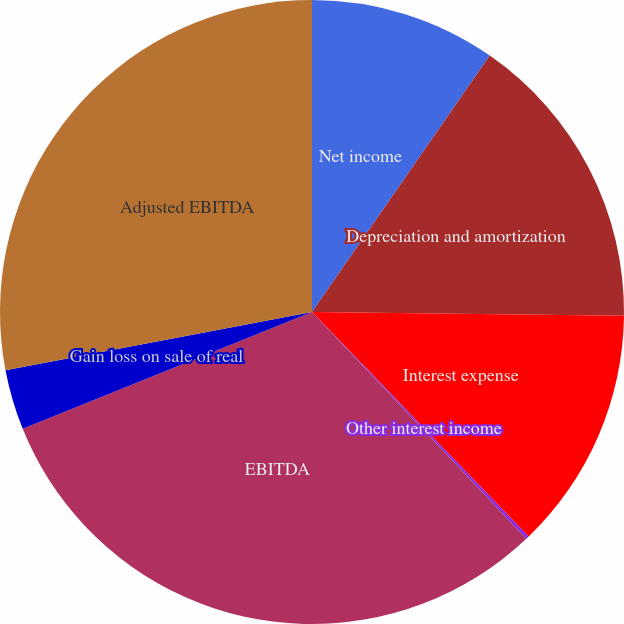Convert chart. <chart><loc_0><loc_0><loc_500><loc_500><pie_chart><fcel>Net income<fcel>Depreciation and amortization<fcel>Interest expense<fcel>Other interest income<fcel>EBITDA<fcel>Gain loss on sale of real<fcel>Adjusted EBITDA<nl><fcel>9.65%<fcel>15.54%<fcel>12.59%<fcel>0.17%<fcel>30.94%<fcel>3.12%<fcel>27.99%<nl></chart> 